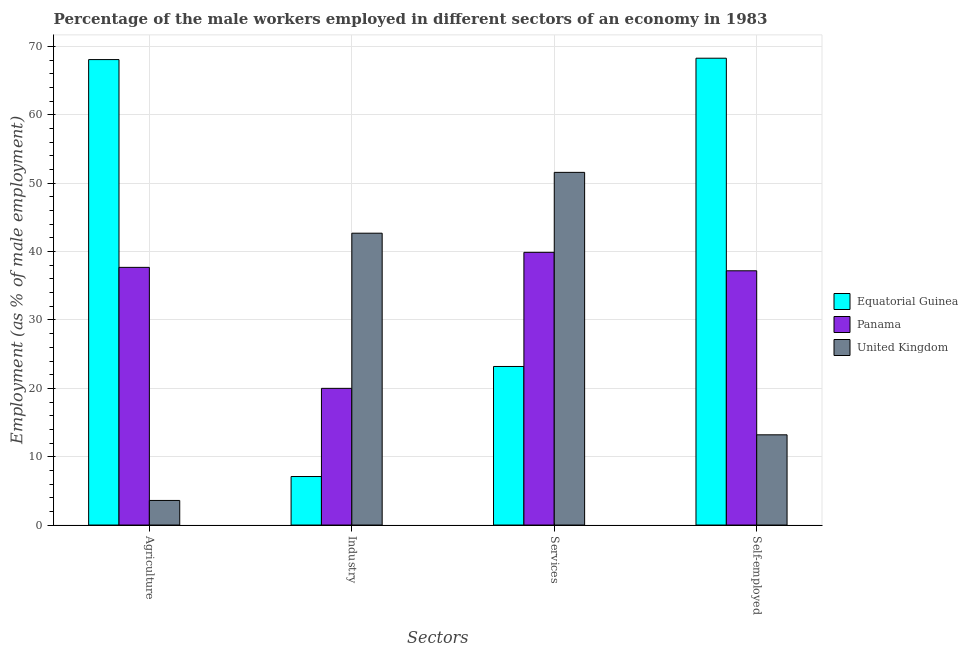How many different coloured bars are there?
Your answer should be compact. 3. Are the number of bars per tick equal to the number of legend labels?
Provide a short and direct response. Yes. Are the number of bars on each tick of the X-axis equal?
Provide a short and direct response. Yes. How many bars are there on the 1st tick from the left?
Give a very brief answer. 3. How many bars are there on the 2nd tick from the right?
Offer a terse response. 3. What is the label of the 3rd group of bars from the left?
Provide a succinct answer. Services. What is the percentage of male workers in agriculture in United Kingdom?
Provide a succinct answer. 3.6. Across all countries, what is the maximum percentage of male workers in agriculture?
Your answer should be compact. 68.1. Across all countries, what is the minimum percentage of male workers in agriculture?
Offer a terse response. 3.6. In which country was the percentage of male workers in agriculture maximum?
Offer a terse response. Equatorial Guinea. What is the total percentage of male workers in industry in the graph?
Your answer should be very brief. 69.8. What is the difference between the percentage of male workers in agriculture in United Kingdom and that in Equatorial Guinea?
Provide a succinct answer. -64.5. What is the difference between the percentage of male workers in agriculture in Panama and the percentage of male workers in services in Equatorial Guinea?
Provide a short and direct response. 14.5. What is the average percentage of self employed male workers per country?
Provide a short and direct response. 39.57. What is the difference between the percentage of male workers in agriculture and percentage of self employed male workers in Equatorial Guinea?
Offer a very short reply. -0.2. In how many countries, is the percentage of male workers in agriculture greater than 50 %?
Provide a short and direct response. 1. What is the ratio of the percentage of male workers in agriculture in Panama to that in United Kingdom?
Give a very brief answer. 10.47. Is the percentage of male workers in services in United Kingdom less than that in Panama?
Your answer should be compact. No. What is the difference between the highest and the second highest percentage of male workers in industry?
Provide a succinct answer. 22.7. What is the difference between the highest and the lowest percentage of male workers in agriculture?
Provide a succinct answer. 64.5. In how many countries, is the percentage of self employed male workers greater than the average percentage of self employed male workers taken over all countries?
Offer a terse response. 1. Is the sum of the percentage of male workers in services in Panama and United Kingdom greater than the maximum percentage of male workers in agriculture across all countries?
Offer a terse response. Yes. Is it the case that in every country, the sum of the percentage of male workers in services and percentage of self employed male workers is greater than the sum of percentage of male workers in industry and percentage of male workers in agriculture?
Your answer should be compact. Yes. What does the 3rd bar from the right in Services represents?
Give a very brief answer. Equatorial Guinea. Are all the bars in the graph horizontal?
Your answer should be very brief. No. How many countries are there in the graph?
Provide a succinct answer. 3. What is the difference between two consecutive major ticks on the Y-axis?
Give a very brief answer. 10. Are the values on the major ticks of Y-axis written in scientific E-notation?
Keep it short and to the point. No. Does the graph contain grids?
Your answer should be compact. Yes. Where does the legend appear in the graph?
Provide a succinct answer. Center right. How many legend labels are there?
Offer a terse response. 3. What is the title of the graph?
Ensure brevity in your answer.  Percentage of the male workers employed in different sectors of an economy in 1983. What is the label or title of the X-axis?
Your answer should be compact. Sectors. What is the label or title of the Y-axis?
Your answer should be compact. Employment (as % of male employment). What is the Employment (as % of male employment) of Equatorial Guinea in Agriculture?
Make the answer very short. 68.1. What is the Employment (as % of male employment) in Panama in Agriculture?
Your response must be concise. 37.7. What is the Employment (as % of male employment) of United Kingdom in Agriculture?
Make the answer very short. 3.6. What is the Employment (as % of male employment) of Equatorial Guinea in Industry?
Give a very brief answer. 7.1. What is the Employment (as % of male employment) in United Kingdom in Industry?
Your answer should be very brief. 42.7. What is the Employment (as % of male employment) of Equatorial Guinea in Services?
Offer a very short reply. 23.2. What is the Employment (as % of male employment) of Panama in Services?
Offer a terse response. 39.9. What is the Employment (as % of male employment) of United Kingdom in Services?
Your answer should be very brief. 51.6. What is the Employment (as % of male employment) in Equatorial Guinea in Self-employed?
Offer a very short reply. 68.3. What is the Employment (as % of male employment) in Panama in Self-employed?
Offer a very short reply. 37.2. What is the Employment (as % of male employment) in United Kingdom in Self-employed?
Provide a short and direct response. 13.2. Across all Sectors, what is the maximum Employment (as % of male employment) of Equatorial Guinea?
Your response must be concise. 68.3. Across all Sectors, what is the maximum Employment (as % of male employment) of Panama?
Your answer should be very brief. 39.9. Across all Sectors, what is the maximum Employment (as % of male employment) of United Kingdom?
Your answer should be compact. 51.6. Across all Sectors, what is the minimum Employment (as % of male employment) of Equatorial Guinea?
Your answer should be very brief. 7.1. Across all Sectors, what is the minimum Employment (as % of male employment) of United Kingdom?
Your response must be concise. 3.6. What is the total Employment (as % of male employment) in Equatorial Guinea in the graph?
Your answer should be very brief. 166.7. What is the total Employment (as % of male employment) of Panama in the graph?
Your answer should be very brief. 134.8. What is the total Employment (as % of male employment) in United Kingdom in the graph?
Make the answer very short. 111.1. What is the difference between the Employment (as % of male employment) of United Kingdom in Agriculture and that in Industry?
Your answer should be very brief. -39.1. What is the difference between the Employment (as % of male employment) in Equatorial Guinea in Agriculture and that in Services?
Give a very brief answer. 44.9. What is the difference between the Employment (as % of male employment) of Panama in Agriculture and that in Services?
Make the answer very short. -2.2. What is the difference between the Employment (as % of male employment) of United Kingdom in Agriculture and that in Services?
Your answer should be compact. -48. What is the difference between the Employment (as % of male employment) in Panama in Agriculture and that in Self-employed?
Provide a succinct answer. 0.5. What is the difference between the Employment (as % of male employment) of Equatorial Guinea in Industry and that in Services?
Give a very brief answer. -16.1. What is the difference between the Employment (as % of male employment) in Panama in Industry and that in Services?
Provide a succinct answer. -19.9. What is the difference between the Employment (as % of male employment) in Equatorial Guinea in Industry and that in Self-employed?
Ensure brevity in your answer.  -61.2. What is the difference between the Employment (as % of male employment) in Panama in Industry and that in Self-employed?
Keep it short and to the point. -17.2. What is the difference between the Employment (as % of male employment) in United Kingdom in Industry and that in Self-employed?
Your answer should be compact. 29.5. What is the difference between the Employment (as % of male employment) in Equatorial Guinea in Services and that in Self-employed?
Your answer should be compact. -45.1. What is the difference between the Employment (as % of male employment) in United Kingdom in Services and that in Self-employed?
Make the answer very short. 38.4. What is the difference between the Employment (as % of male employment) of Equatorial Guinea in Agriculture and the Employment (as % of male employment) of Panama in Industry?
Keep it short and to the point. 48.1. What is the difference between the Employment (as % of male employment) in Equatorial Guinea in Agriculture and the Employment (as % of male employment) in United Kingdom in Industry?
Give a very brief answer. 25.4. What is the difference between the Employment (as % of male employment) in Equatorial Guinea in Agriculture and the Employment (as % of male employment) in Panama in Services?
Offer a terse response. 28.2. What is the difference between the Employment (as % of male employment) in Equatorial Guinea in Agriculture and the Employment (as % of male employment) in United Kingdom in Services?
Your response must be concise. 16.5. What is the difference between the Employment (as % of male employment) in Equatorial Guinea in Agriculture and the Employment (as % of male employment) in Panama in Self-employed?
Offer a very short reply. 30.9. What is the difference between the Employment (as % of male employment) in Equatorial Guinea in Agriculture and the Employment (as % of male employment) in United Kingdom in Self-employed?
Give a very brief answer. 54.9. What is the difference between the Employment (as % of male employment) of Equatorial Guinea in Industry and the Employment (as % of male employment) of Panama in Services?
Offer a very short reply. -32.8. What is the difference between the Employment (as % of male employment) of Equatorial Guinea in Industry and the Employment (as % of male employment) of United Kingdom in Services?
Offer a very short reply. -44.5. What is the difference between the Employment (as % of male employment) of Panama in Industry and the Employment (as % of male employment) of United Kingdom in Services?
Offer a terse response. -31.6. What is the difference between the Employment (as % of male employment) in Equatorial Guinea in Industry and the Employment (as % of male employment) in Panama in Self-employed?
Your answer should be compact. -30.1. What is the difference between the Employment (as % of male employment) of Equatorial Guinea in Services and the Employment (as % of male employment) of United Kingdom in Self-employed?
Keep it short and to the point. 10. What is the difference between the Employment (as % of male employment) of Panama in Services and the Employment (as % of male employment) of United Kingdom in Self-employed?
Make the answer very short. 26.7. What is the average Employment (as % of male employment) in Equatorial Guinea per Sectors?
Give a very brief answer. 41.67. What is the average Employment (as % of male employment) of Panama per Sectors?
Ensure brevity in your answer.  33.7. What is the average Employment (as % of male employment) in United Kingdom per Sectors?
Your answer should be compact. 27.77. What is the difference between the Employment (as % of male employment) in Equatorial Guinea and Employment (as % of male employment) in Panama in Agriculture?
Offer a very short reply. 30.4. What is the difference between the Employment (as % of male employment) of Equatorial Guinea and Employment (as % of male employment) of United Kingdom in Agriculture?
Your answer should be compact. 64.5. What is the difference between the Employment (as % of male employment) of Panama and Employment (as % of male employment) of United Kingdom in Agriculture?
Ensure brevity in your answer.  34.1. What is the difference between the Employment (as % of male employment) in Equatorial Guinea and Employment (as % of male employment) in Panama in Industry?
Your answer should be very brief. -12.9. What is the difference between the Employment (as % of male employment) in Equatorial Guinea and Employment (as % of male employment) in United Kingdom in Industry?
Provide a short and direct response. -35.6. What is the difference between the Employment (as % of male employment) of Panama and Employment (as % of male employment) of United Kingdom in Industry?
Provide a short and direct response. -22.7. What is the difference between the Employment (as % of male employment) of Equatorial Guinea and Employment (as % of male employment) of Panama in Services?
Your answer should be very brief. -16.7. What is the difference between the Employment (as % of male employment) of Equatorial Guinea and Employment (as % of male employment) of United Kingdom in Services?
Provide a short and direct response. -28.4. What is the difference between the Employment (as % of male employment) in Panama and Employment (as % of male employment) in United Kingdom in Services?
Provide a succinct answer. -11.7. What is the difference between the Employment (as % of male employment) of Equatorial Guinea and Employment (as % of male employment) of Panama in Self-employed?
Make the answer very short. 31.1. What is the difference between the Employment (as % of male employment) of Equatorial Guinea and Employment (as % of male employment) of United Kingdom in Self-employed?
Your response must be concise. 55.1. What is the ratio of the Employment (as % of male employment) in Equatorial Guinea in Agriculture to that in Industry?
Make the answer very short. 9.59. What is the ratio of the Employment (as % of male employment) of Panama in Agriculture to that in Industry?
Give a very brief answer. 1.89. What is the ratio of the Employment (as % of male employment) of United Kingdom in Agriculture to that in Industry?
Your answer should be very brief. 0.08. What is the ratio of the Employment (as % of male employment) of Equatorial Guinea in Agriculture to that in Services?
Your answer should be very brief. 2.94. What is the ratio of the Employment (as % of male employment) in Panama in Agriculture to that in Services?
Provide a short and direct response. 0.94. What is the ratio of the Employment (as % of male employment) in United Kingdom in Agriculture to that in Services?
Give a very brief answer. 0.07. What is the ratio of the Employment (as % of male employment) in Panama in Agriculture to that in Self-employed?
Give a very brief answer. 1.01. What is the ratio of the Employment (as % of male employment) of United Kingdom in Agriculture to that in Self-employed?
Provide a short and direct response. 0.27. What is the ratio of the Employment (as % of male employment) in Equatorial Guinea in Industry to that in Services?
Offer a very short reply. 0.31. What is the ratio of the Employment (as % of male employment) of Panama in Industry to that in Services?
Provide a succinct answer. 0.5. What is the ratio of the Employment (as % of male employment) of United Kingdom in Industry to that in Services?
Your answer should be compact. 0.83. What is the ratio of the Employment (as % of male employment) in Equatorial Guinea in Industry to that in Self-employed?
Provide a succinct answer. 0.1. What is the ratio of the Employment (as % of male employment) in Panama in Industry to that in Self-employed?
Offer a very short reply. 0.54. What is the ratio of the Employment (as % of male employment) of United Kingdom in Industry to that in Self-employed?
Your response must be concise. 3.23. What is the ratio of the Employment (as % of male employment) of Equatorial Guinea in Services to that in Self-employed?
Provide a short and direct response. 0.34. What is the ratio of the Employment (as % of male employment) of Panama in Services to that in Self-employed?
Your answer should be compact. 1.07. What is the ratio of the Employment (as % of male employment) of United Kingdom in Services to that in Self-employed?
Your response must be concise. 3.91. What is the difference between the highest and the second highest Employment (as % of male employment) of Panama?
Your response must be concise. 2.2. What is the difference between the highest and the lowest Employment (as % of male employment) in Equatorial Guinea?
Keep it short and to the point. 61.2. What is the difference between the highest and the lowest Employment (as % of male employment) in Panama?
Keep it short and to the point. 19.9. 